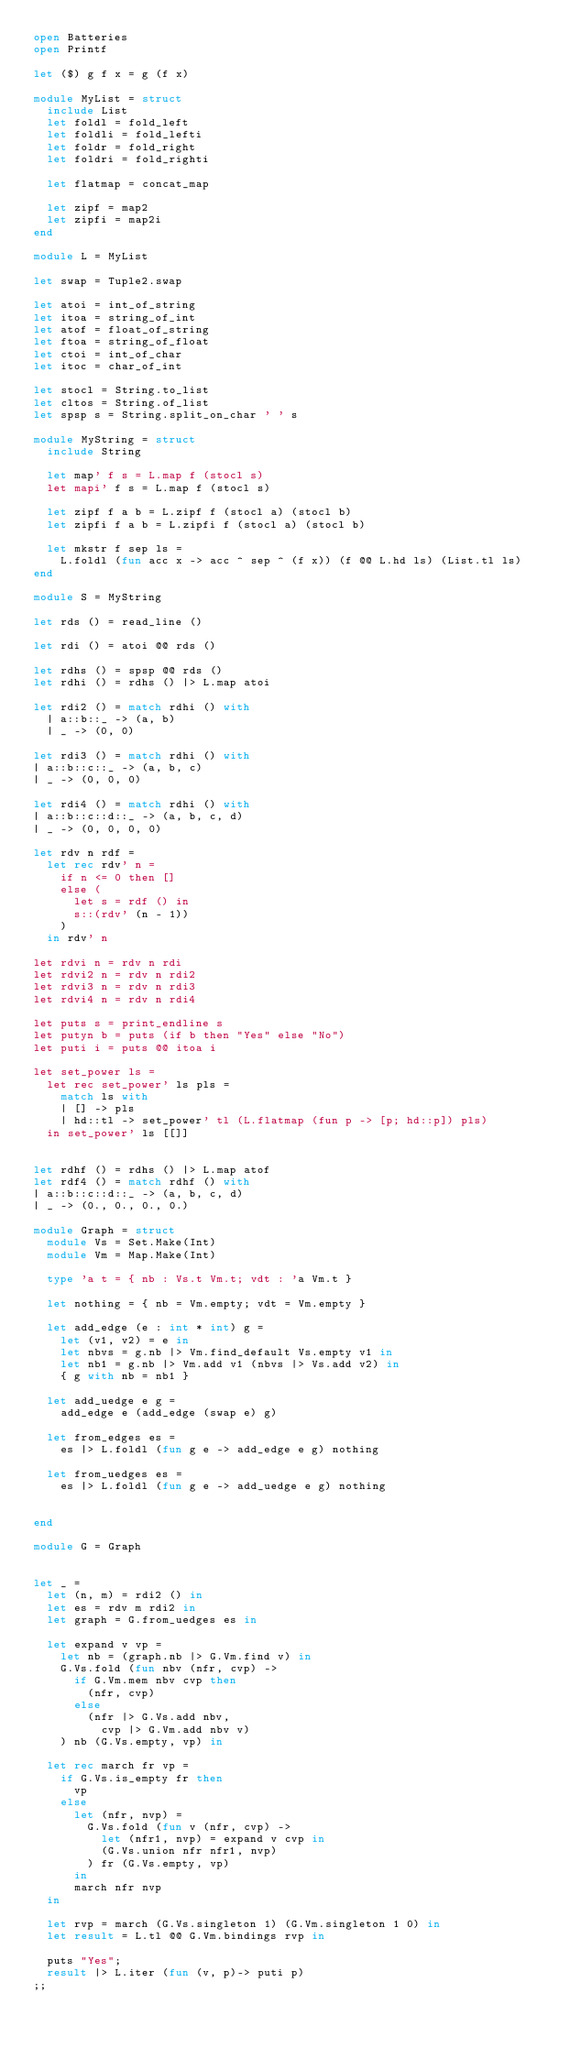<code> <loc_0><loc_0><loc_500><loc_500><_OCaml_>open Batteries
open Printf

let ($) g f x = g (f x)

module MyList = struct
  include List
  let foldl = fold_left
  let foldli = fold_lefti
  let foldr = fold_right
  let foldri = fold_righti
  
  let flatmap = concat_map

  let zipf = map2
  let zipfi = map2i
end

module L = MyList

let swap = Tuple2.swap

let atoi = int_of_string
let itoa = string_of_int
let atof = float_of_string
let ftoa = string_of_float
let ctoi = int_of_char
let itoc = char_of_int

let stocl = String.to_list
let cltos = String.of_list
let spsp s = String.split_on_char ' ' s

module MyString = struct
  include String

  let map' f s = L.map f (stocl s)
  let mapi' f s = L.map f (stocl s)

  let zipf f a b = L.zipf f (stocl a) (stocl b)
  let zipfi f a b = L.zipfi f (stocl a) (stocl b)

  let mkstr f sep ls =
    L.foldl (fun acc x -> acc ^ sep ^ (f x)) (f @@ L.hd ls) (List.tl ls)
end

module S = MyString

let rds () = read_line ()

let rdi () = atoi @@ rds ()

let rdhs () = spsp @@ rds ()
let rdhi () = rdhs () |> L.map atoi

let rdi2 () = match rdhi () with
  | a::b::_ -> (a, b)
  | _ -> (0, 0)

let rdi3 () = match rdhi () with
| a::b::c::_ -> (a, b, c)
| _ -> (0, 0, 0)

let rdi4 () = match rdhi () with
| a::b::c::d::_ -> (a, b, c, d)
| _ -> (0, 0, 0, 0)

let rdv n rdf =
  let rec rdv' n =
    if n <= 0 then []
    else (
      let s = rdf () in
      s::(rdv' (n - 1))
    )
  in rdv' n

let rdvi n = rdv n rdi
let rdvi2 n = rdv n rdi2
let rdvi3 n = rdv n rdi3
let rdvi4 n = rdv n rdi4

let puts s = print_endline s
let putyn b = puts (if b then "Yes" else "No")
let puti i = puts @@ itoa i

let set_power ls =
  let rec set_power' ls pls =
    match ls with
    | [] -> pls
    | hd::tl -> set_power' tl (L.flatmap (fun p -> [p; hd::p]) pls)
  in set_power' ls [[]]


let rdhf () = rdhs () |> L.map atof
let rdf4 () = match rdhf () with
| a::b::c::d::_ -> (a, b, c, d)
| _ -> (0., 0., 0., 0.)

module Graph = struct
  module Vs = Set.Make(Int)
  module Vm = Map.Make(Int)
  
  type 'a t = { nb : Vs.t Vm.t; vdt : 'a Vm.t }

  let nothing = { nb = Vm.empty; vdt = Vm.empty }

  let add_edge (e : int * int) g =
    let (v1, v2) = e in
    let nbvs = g.nb |> Vm.find_default Vs.empty v1 in
    let nb1 = g.nb |> Vm.add v1 (nbvs |> Vs.add v2) in
    { g with nb = nb1 }

  let add_uedge e g =
    add_edge e (add_edge (swap e) g)

  let from_edges es =
    es |> L.foldl (fun g e -> add_edge e g) nothing

  let from_uedges es =
    es |> L.foldl (fun g e -> add_uedge e g) nothing


end

module G = Graph


let _ =
  let (n, m) = rdi2 () in
  let es = rdv m rdi2 in
  let graph = G.from_uedges es in

  let expand v vp =
    let nb = (graph.nb |> G.Vm.find v) in
    G.Vs.fold (fun nbv (nfr, cvp) ->
      if G.Vm.mem nbv cvp then
        (nfr, cvp)
      else
        (nfr |> G.Vs.add nbv,
          cvp |> G.Vm.add nbv v)
    ) nb (G.Vs.empty, vp) in
  
  let rec march fr vp =
    if G.Vs.is_empty fr then
      vp
    else
      let (nfr, nvp) =
        G.Vs.fold (fun v (nfr, cvp) ->
          let (nfr1, nvp) = expand v cvp in
          (G.Vs.union nfr nfr1, nvp)
        ) fr (G.Vs.empty, vp)
      in
      march nfr nvp 
  in

  let rvp = march (G.Vs.singleton 1) (G.Vm.singleton 1 0) in
  let result = L.tl @@ G.Vm.bindings rvp in

  puts "Yes";
  result |> L.iter (fun (v, p)-> puti p)
;;
</code> 